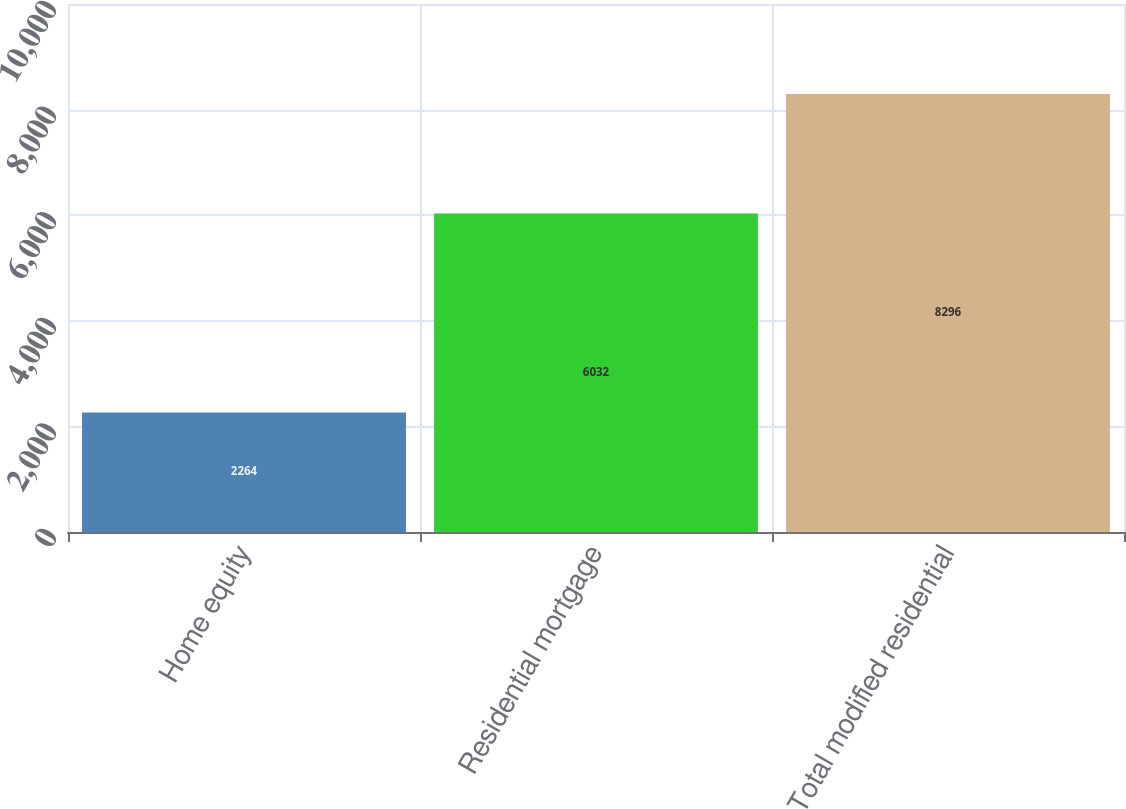<chart> <loc_0><loc_0><loc_500><loc_500><bar_chart><fcel>Home equity<fcel>Residential mortgage<fcel>Total modified residential<nl><fcel>2264<fcel>6032<fcel>8296<nl></chart> 